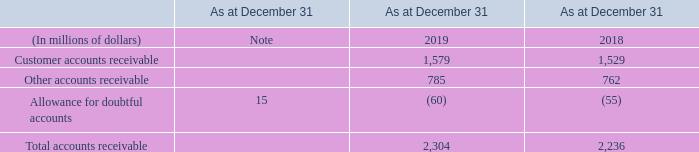ACCOUNTING POLICY
Accounts receivable represent amounts owing to us that are currently due and collectible. We initially recognize accounts receivable on the date they originate. We measure accounts receivable initially at fair value, and subsequently at amortized cost, with changes recognized in net income. We measure an impairment loss for accounts receivable as the excess of the carrying amount over the present value of future cash flows we expect to derive from it, if any. The excess is allocated to an allowance for doubtful accounts and recognized as a loss in net income.
EXPLANATORY INFORMATION
We have retrospectively reclassified $23 million as at December 31, 2018 and January 1, 2019 related to our wireless financing programs from “accounts receivable” to “other current assets” as the collection time frame of the amounts differs from accounts receivable.
What does Accounts receivable represent? Accounts receivable represent amounts owing to us that are currently due and collectible. we initially recognize accounts receivable on the date they originate. How is accounts receivable measured? We measure accounts receivable initially at fair value, and subsequently at amortized cost, with changes recognized in net income. How is impairment loss for accounts receivable measured? We measure an impairment loss for accounts receivable as the excess of the carrying amount over the present value of future cash flows we expect to derive from it, if any. What is the increase/ (decrease) in Customer accounts receivable from 2018 to 2019?
Answer scale should be: million. 1,579-1,529
Answer: 50. What is the increase/ (decrease) in Other accounts receivable from 2018 to 2019?
Answer scale should be: million. 785-762
Answer: 23. What is the increase/ (decrease) in Allowance for doubtful accounts from 2018 to 2019?
Answer scale should be: million. 60-55
Answer: 5. 